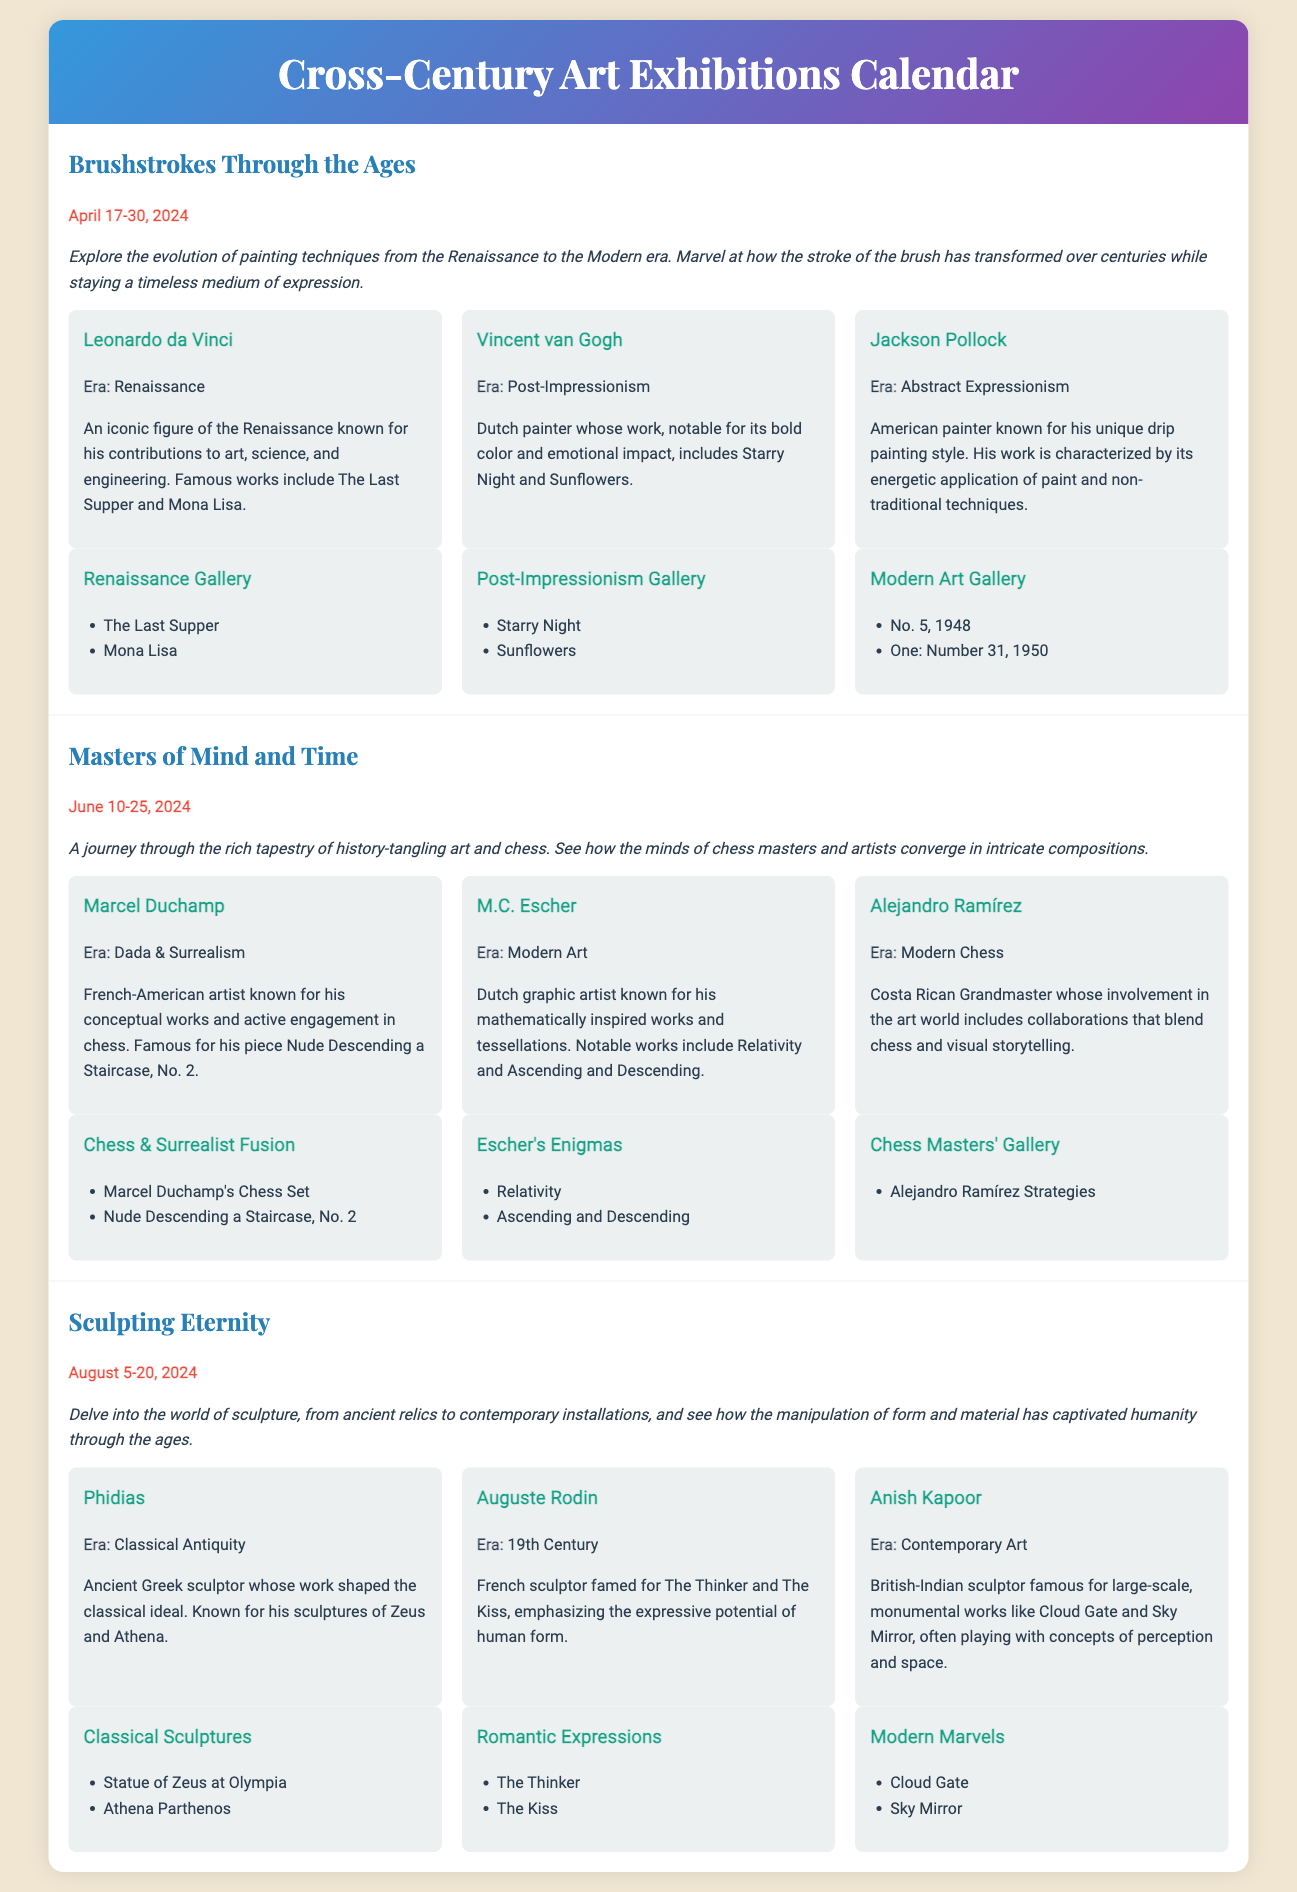What is the title of the first exhibition? The title of the first exhibition is listed as the main heading under the exhibition's details.
Answer: Brushstrokes Through the Ages Who is featured in the first exhibition? The artists in the first exhibition are mentioned under the artists section of the exhibition.
Answer: Leonardo da Vinci, Vincent van Gogh, Jackson Pollock What are the dates for the "Masters of Mind and Time" exhibition? The dates can be found in bold under the exhibition title.
Answer: June 10-25, 2024 Which artist is known for the piece "The Thinker"? The artist associated with "The Thinker" is stated in the artist profiles within the exhibition's details.
Answer: Auguste Rodin What is the main theme of the "Sculpting Eternity" exhibition? The theme is provided in the description under the exhibition title, explaining the focus on sculptures.
Answer: Sculpture, ancient relics to contemporary installations How many galleries are there in the "Brushstrokes Through the Ages" exhibition? The number of galleries can be counted from the layout section of the exhibition, listing each gallery's title.
Answer: 3 Which gallery features M.C. Escher's works? The gallery listing is presented in the layout section with specific works associated with each artist.
Answer: Escher's Enigmas How is Marcel Duchamp related to chess? The relationship is explained in the artist's profile under the "Masters of Mind and Time" exhibition.
Answer: Active engagement in chess What is the date range for the "Sculpting Eternity" exhibition? The date range is provided in bold text under the exhibition title for specific details.
Answer: August 5-20, 2024 